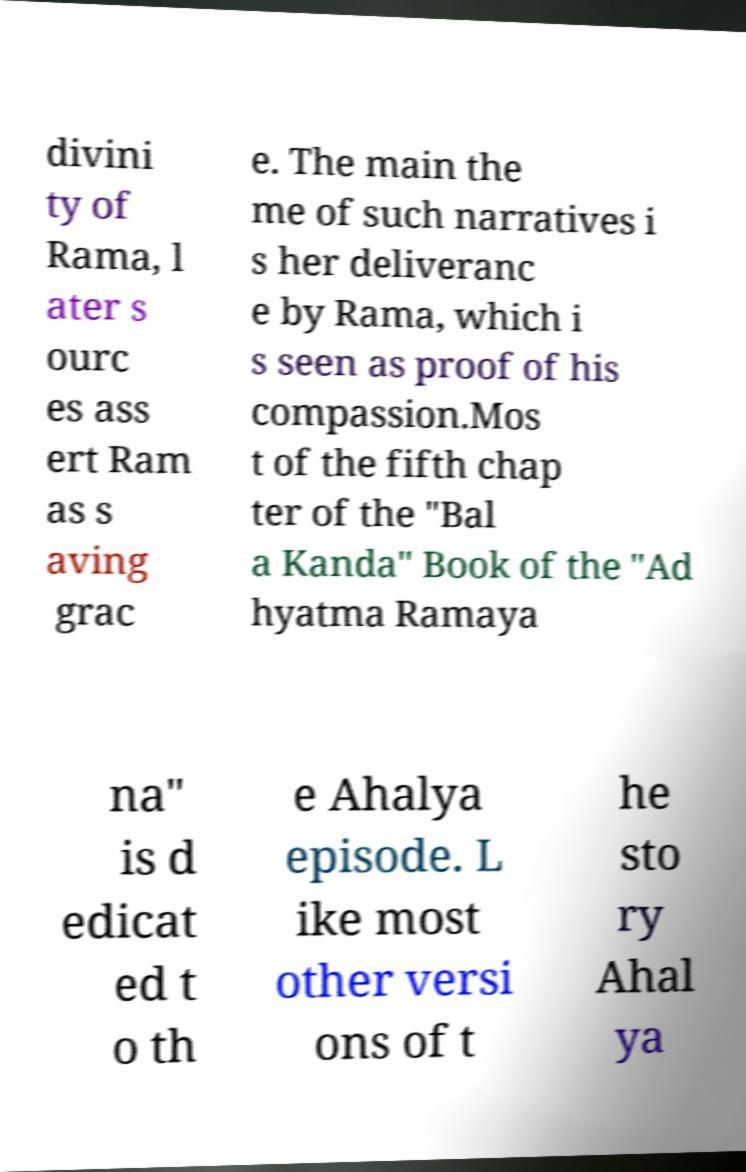For documentation purposes, I need the text within this image transcribed. Could you provide that? divini ty of Rama, l ater s ourc es ass ert Ram as s aving grac e. The main the me of such narratives i s her deliveranc e by Rama, which i s seen as proof of his compassion.Mos t of the fifth chap ter of the "Bal a Kanda" Book of the "Ad hyatma Ramaya na" is d edicat ed t o th e Ahalya episode. L ike most other versi ons of t he sto ry Ahal ya 